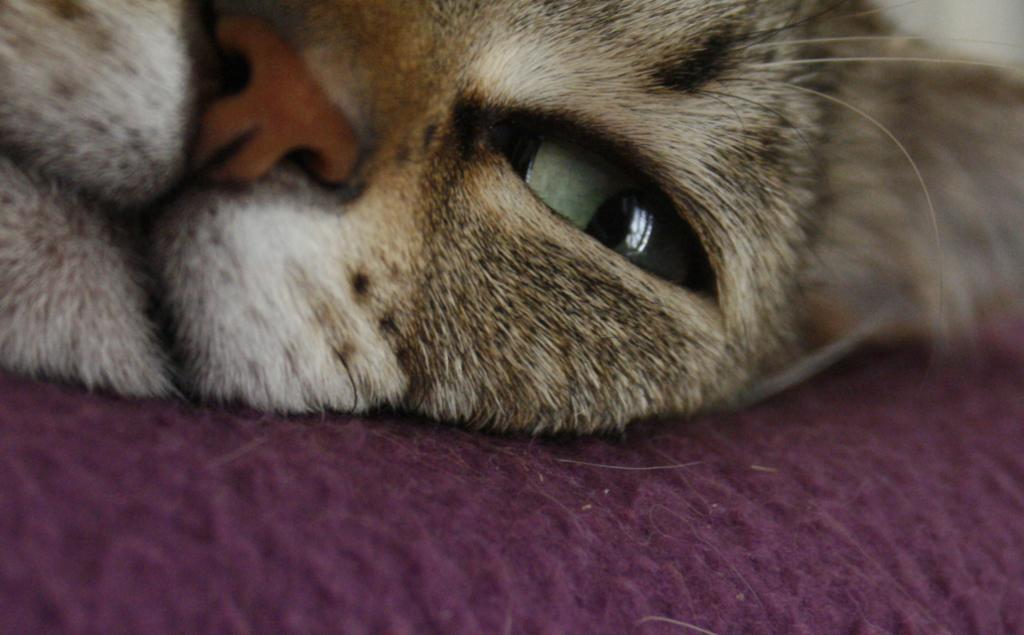Please provide a concise description of this image. In this image, we can see a cat on the cloth. 